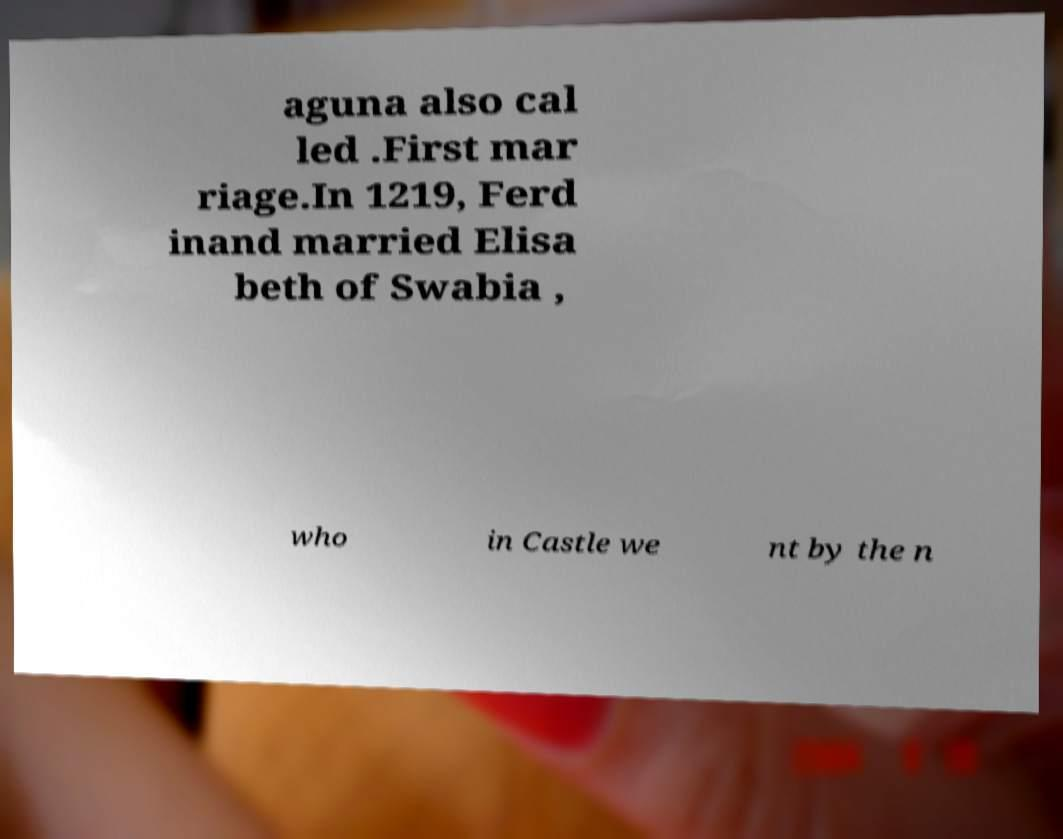Could you assist in decoding the text presented in this image and type it out clearly? aguna also cal led .First mar riage.In 1219, Ferd inand married Elisa beth of Swabia , who in Castle we nt by the n 